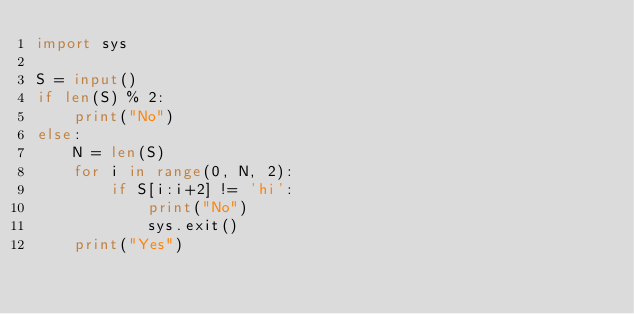Convert code to text. <code><loc_0><loc_0><loc_500><loc_500><_Python_>import sys

S = input()
if len(S) % 2:
    print("No")
else:
    N = len(S)
    for i in range(0, N, 2):
        if S[i:i+2] != 'hi':
            print("No")
            sys.exit()
    print("Yes")</code> 